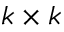Convert formula to latex. <formula><loc_0><loc_0><loc_500><loc_500>k \times k</formula> 